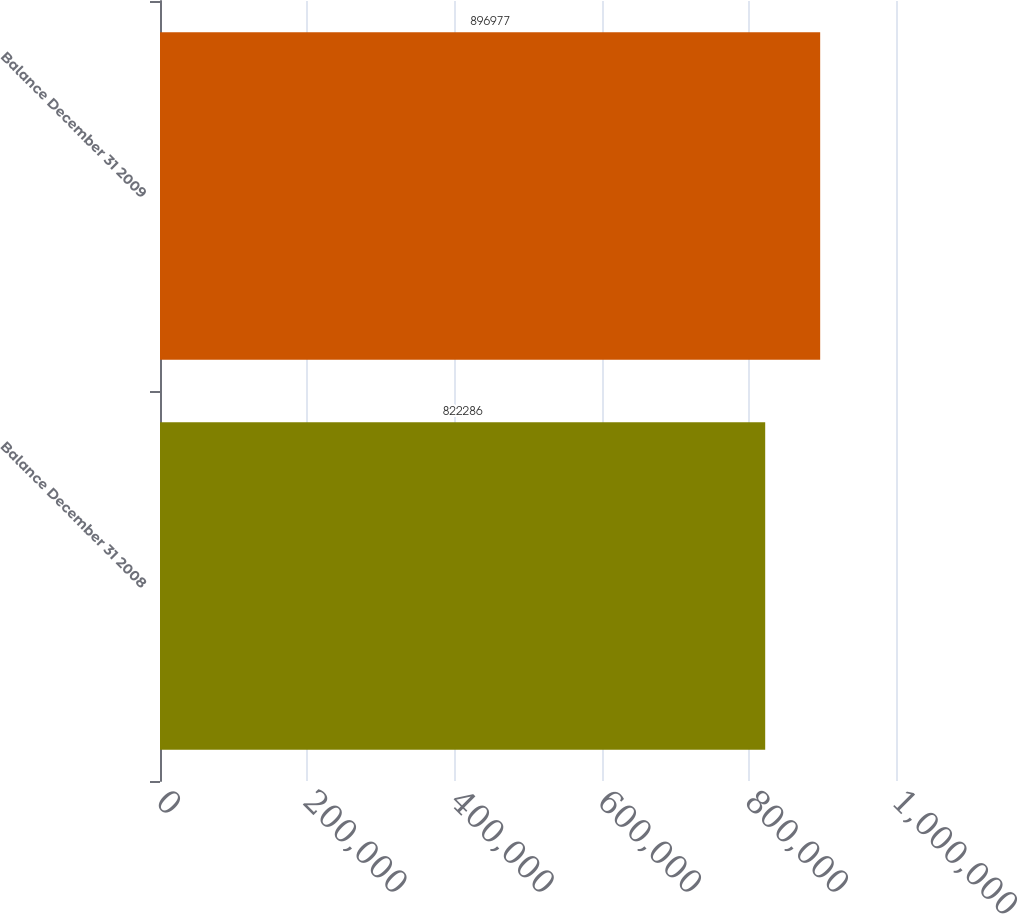<chart> <loc_0><loc_0><loc_500><loc_500><bar_chart><fcel>Balance December 31 2008<fcel>Balance December 31 2009<nl><fcel>822286<fcel>896977<nl></chart> 